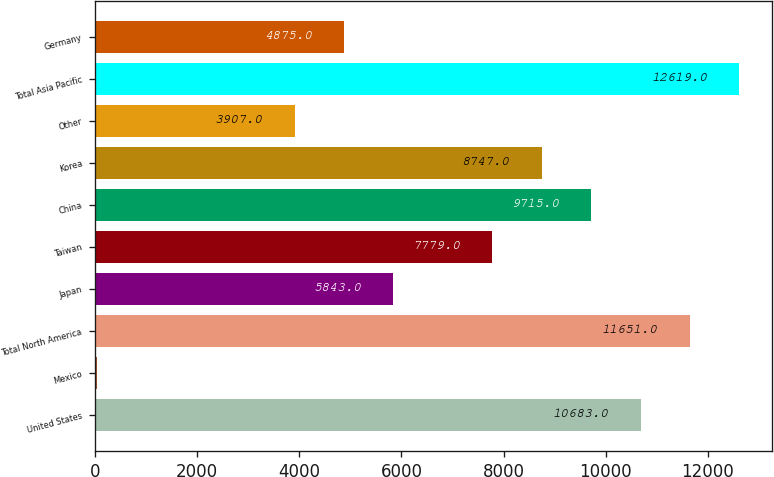<chart> <loc_0><loc_0><loc_500><loc_500><bar_chart><fcel>United States<fcel>Mexico<fcel>Total North America<fcel>Japan<fcel>Taiwan<fcel>China<fcel>Korea<fcel>Other<fcel>Total Asia Pacific<fcel>Germany<nl><fcel>10683<fcel>35<fcel>11651<fcel>5843<fcel>7779<fcel>9715<fcel>8747<fcel>3907<fcel>12619<fcel>4875<nl></chart> 